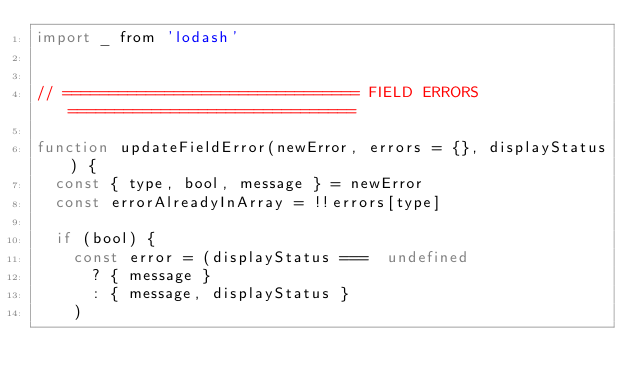<code> <loc_0><loc_0><loc_500><loc_500><_JavaScript_>import _ from 'lodash'


// ================================ FIELD ERRORS ===============================

function updateFieldError(newError, errors = {}, displayStatus) {
  const { type, bool, message } = newError
  const errorAlreadyInArray = !!errors[type]

  if (bool) {
    const error = (displayStatus ===  undefined
      ? { message }
      : { message, displayStatus }
    )</code> 